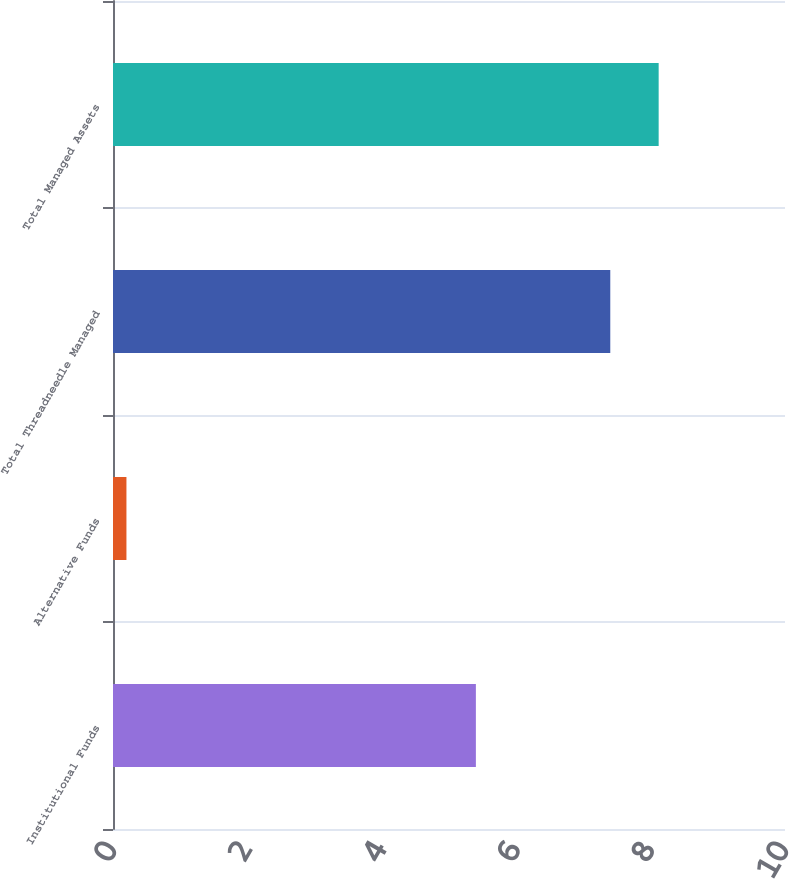Convert chart. <chart><loc_0><loc_0><loc_500><loc_500><bar_chart><fcel>Institutional Funds<fcel>Alternative Funds<fcel>Total Threadneedle Managed<fcel>Total Managed Assets<nl><fcel>5.4<fcel>0.2<fcel>7.4<fcel>8.12<nl></chart> 